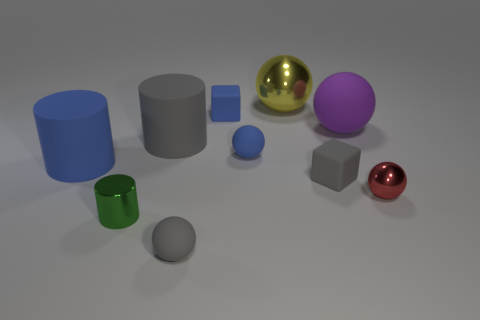There is a yellow thing that is left of the small shiny object that is behind the green metallic object; what shape is it?
Offer a very short reply. Sphere. What number of things are small balls in front of the tiny shiny cylinder or gray objects that are in front of the small gray cube?
Offer a very short reply. 1. What shape is the red object that is made of the same material as the yellow ball?
Your answer should be very brief. Sphere. Are there any other things of the same color as the tiny metallic ball?
Give a very brief answer. No. What material is the other purple object that is the same shape as the large shiny thing?
Keep it short and to the point. Rubber. What number of other objects are the same size as the green metallic object?
Offer a terse response. 5. What is the material of the yellow thing?
Offer a terse response. Metal. Is the number of big purple things on the right side of the gray matte cube greater than the number of green metallic balls?
Your answer should be compact. Yes. Is there a purple rubber cube?
Keep it short and to the point. No. How many other things are the same shape as the green metallic object?
Provide a short and direct response. 2. 